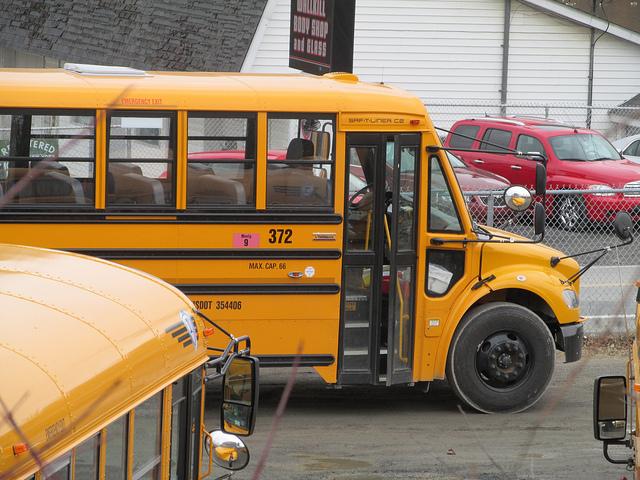What is the first busses number?
Give a very brief answer. 372. Is a bus moving?
Answer briefly. No. What color is the bus?
Answer briefly. Yellow. What kind of business is behind the bus?
Keep it brief. Body shop. 